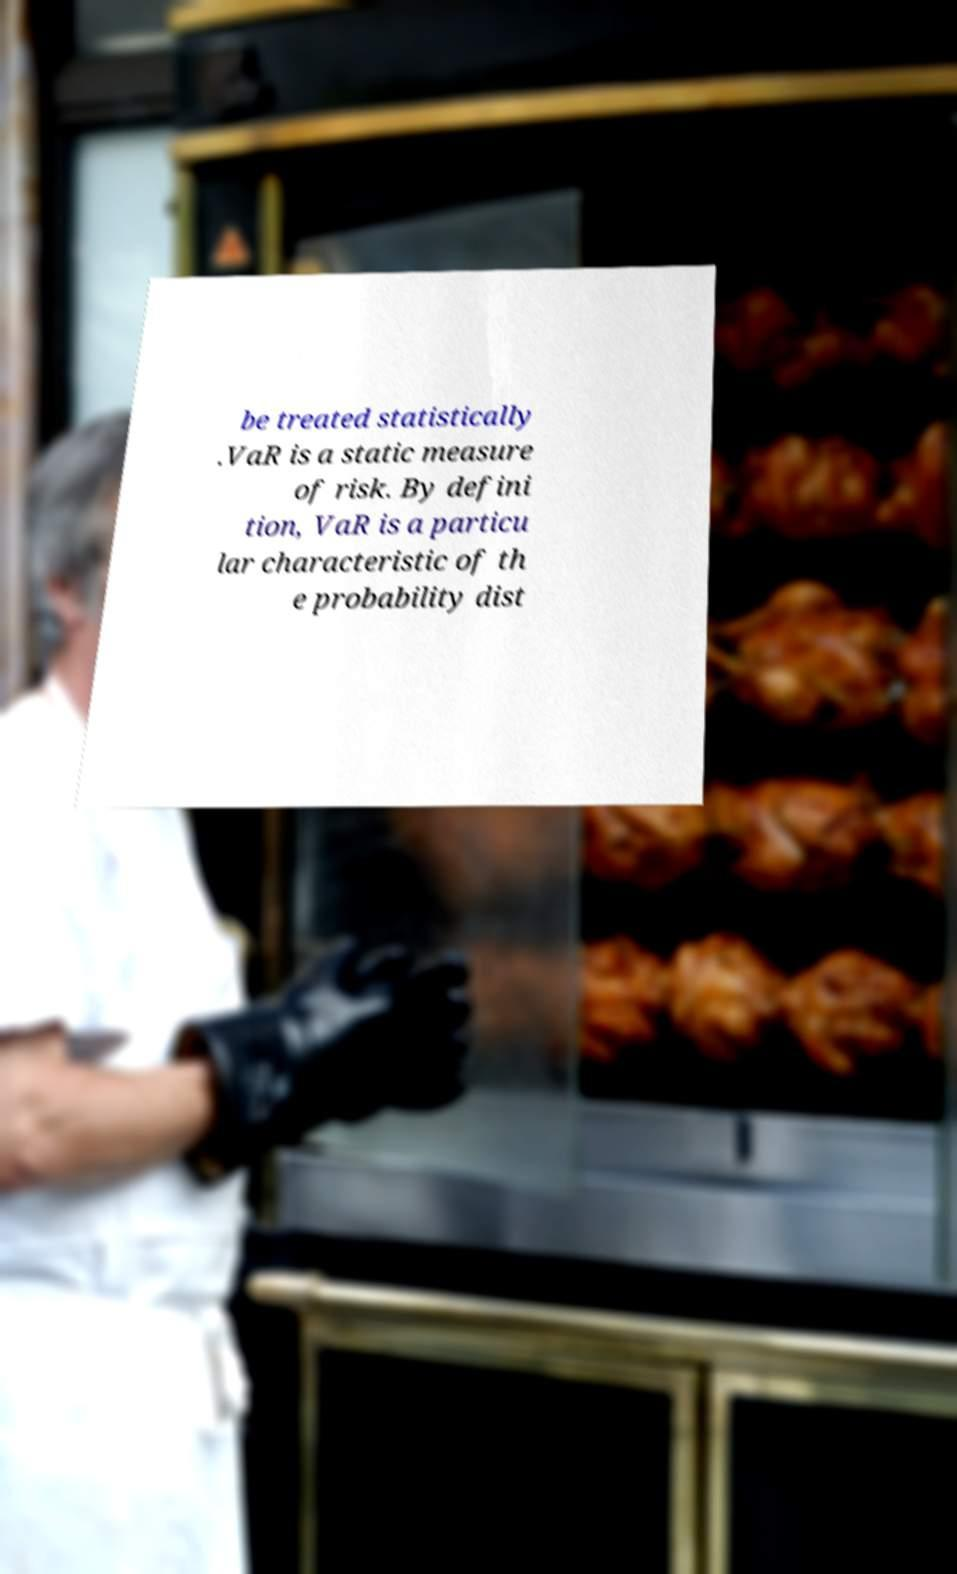Can you read and provide the text displayed in the image?This photo seems to have some interesting text. Can you extract and type it out for me? be treated statistically .VaR is a static measure of risk. By defini tion, VaR is a particu lar characteristic of th e probability dist 